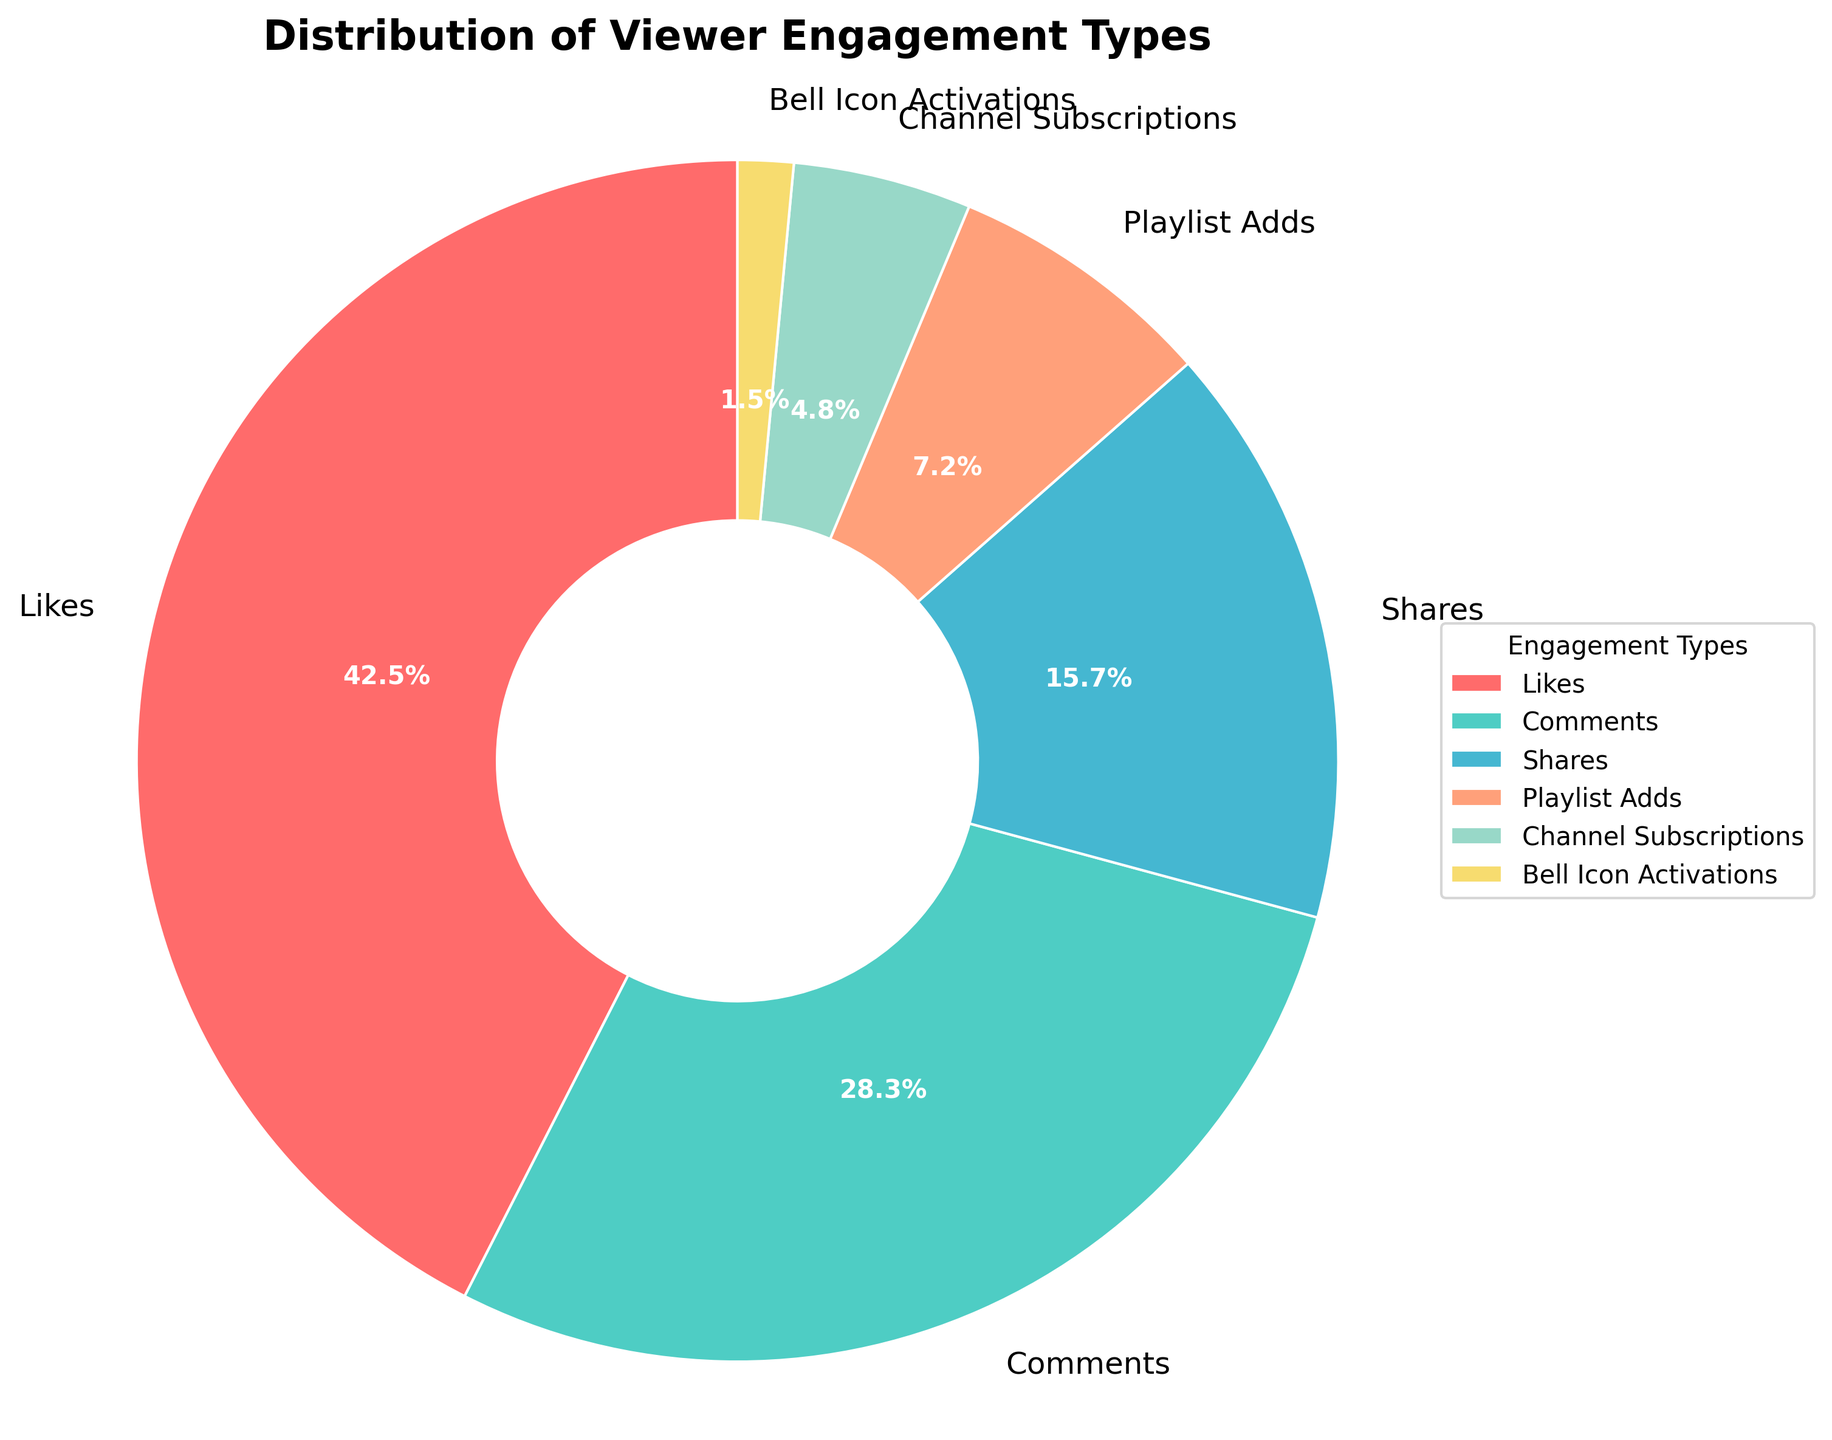What's the most common type of viewer engagement? The most common type of viewer engagement is the one with the highest percentage, which is Likes at 42.5%.
Answer: Likes What's the combined percentage of Comments and Shares? Add the percentages of Comments (28.3%) and Shares (15.7%) together: 28.3 + 15.7 = 44.
Answer: 44% Which engagement type takes up the least amount of the pie chart? The engagement type with the smallest percentage is Bell Icon Activations at 1.5%.
Answer: Bell Icon Activations Are Comments more dominant than Channel Subscriptions? Compare the percentage of Comments (28.3%) to Channel Subscriptions (4.8%). Since 28.3% is greater than 4.8%, Comments are more dominant.
Answer: Yes By how much does the percentage of Likes exceed the percentage of Shares? Subtract the percentage of Shares (15.7%) from the percentage of Likes (42.5%): 42.5 - 15.7 = 26.8.
Answer: 26.8% What is the second most frequent engagement type depicted in the pie chart? The second most common category after Likes (42.5%) is Comments (28.3%).
Answer: Comments Which engagement types together account for more than 50% of the total engagement? Adding Likes (42.5%) and Comments (28.3%) sums up to 70.8%, which is more than 50%.
Answer: Likes and Comments What is the percentage difference between Playlist Adds and Channel Subscriptions? Subtract the percentage of Channel Subscriptions (4.8%) from Playlist Adds (7.2%): 7.2 - 4.8 = 2.4.
Answer: 2.4% What engagement type is represented by the wedge between red and yellow? The wedge between red (Likes) and yellow (Playlist Adds) is light green, which represents Comments (28.3%).
Answer: Comments What's the total contribution of Playlist Adds, Channel Subscriptions, and Bell Icon Activations? Add the percentages of Playlist Adds (7.2%), Channel Subscriptions (4.8%), and Bell Icon Activations (1.5%): 7.2 + 4.8 + 1.5 = 13.5.
Answer: 13.5% 